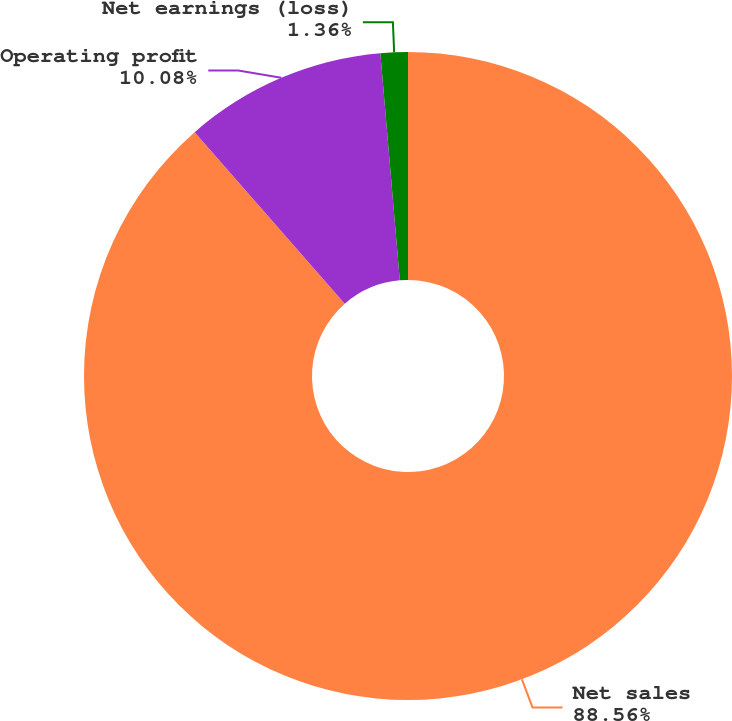Convert chart. <chart><loc_0><loc_0><loc_500><loc_500><pie_chart><fcel>Net sales<fcel>Operating profit<fcel>Net earnings (loss)<nl><fcel>88.57%<fcel>10.08%<fcel>1.36%<nl></chart> 